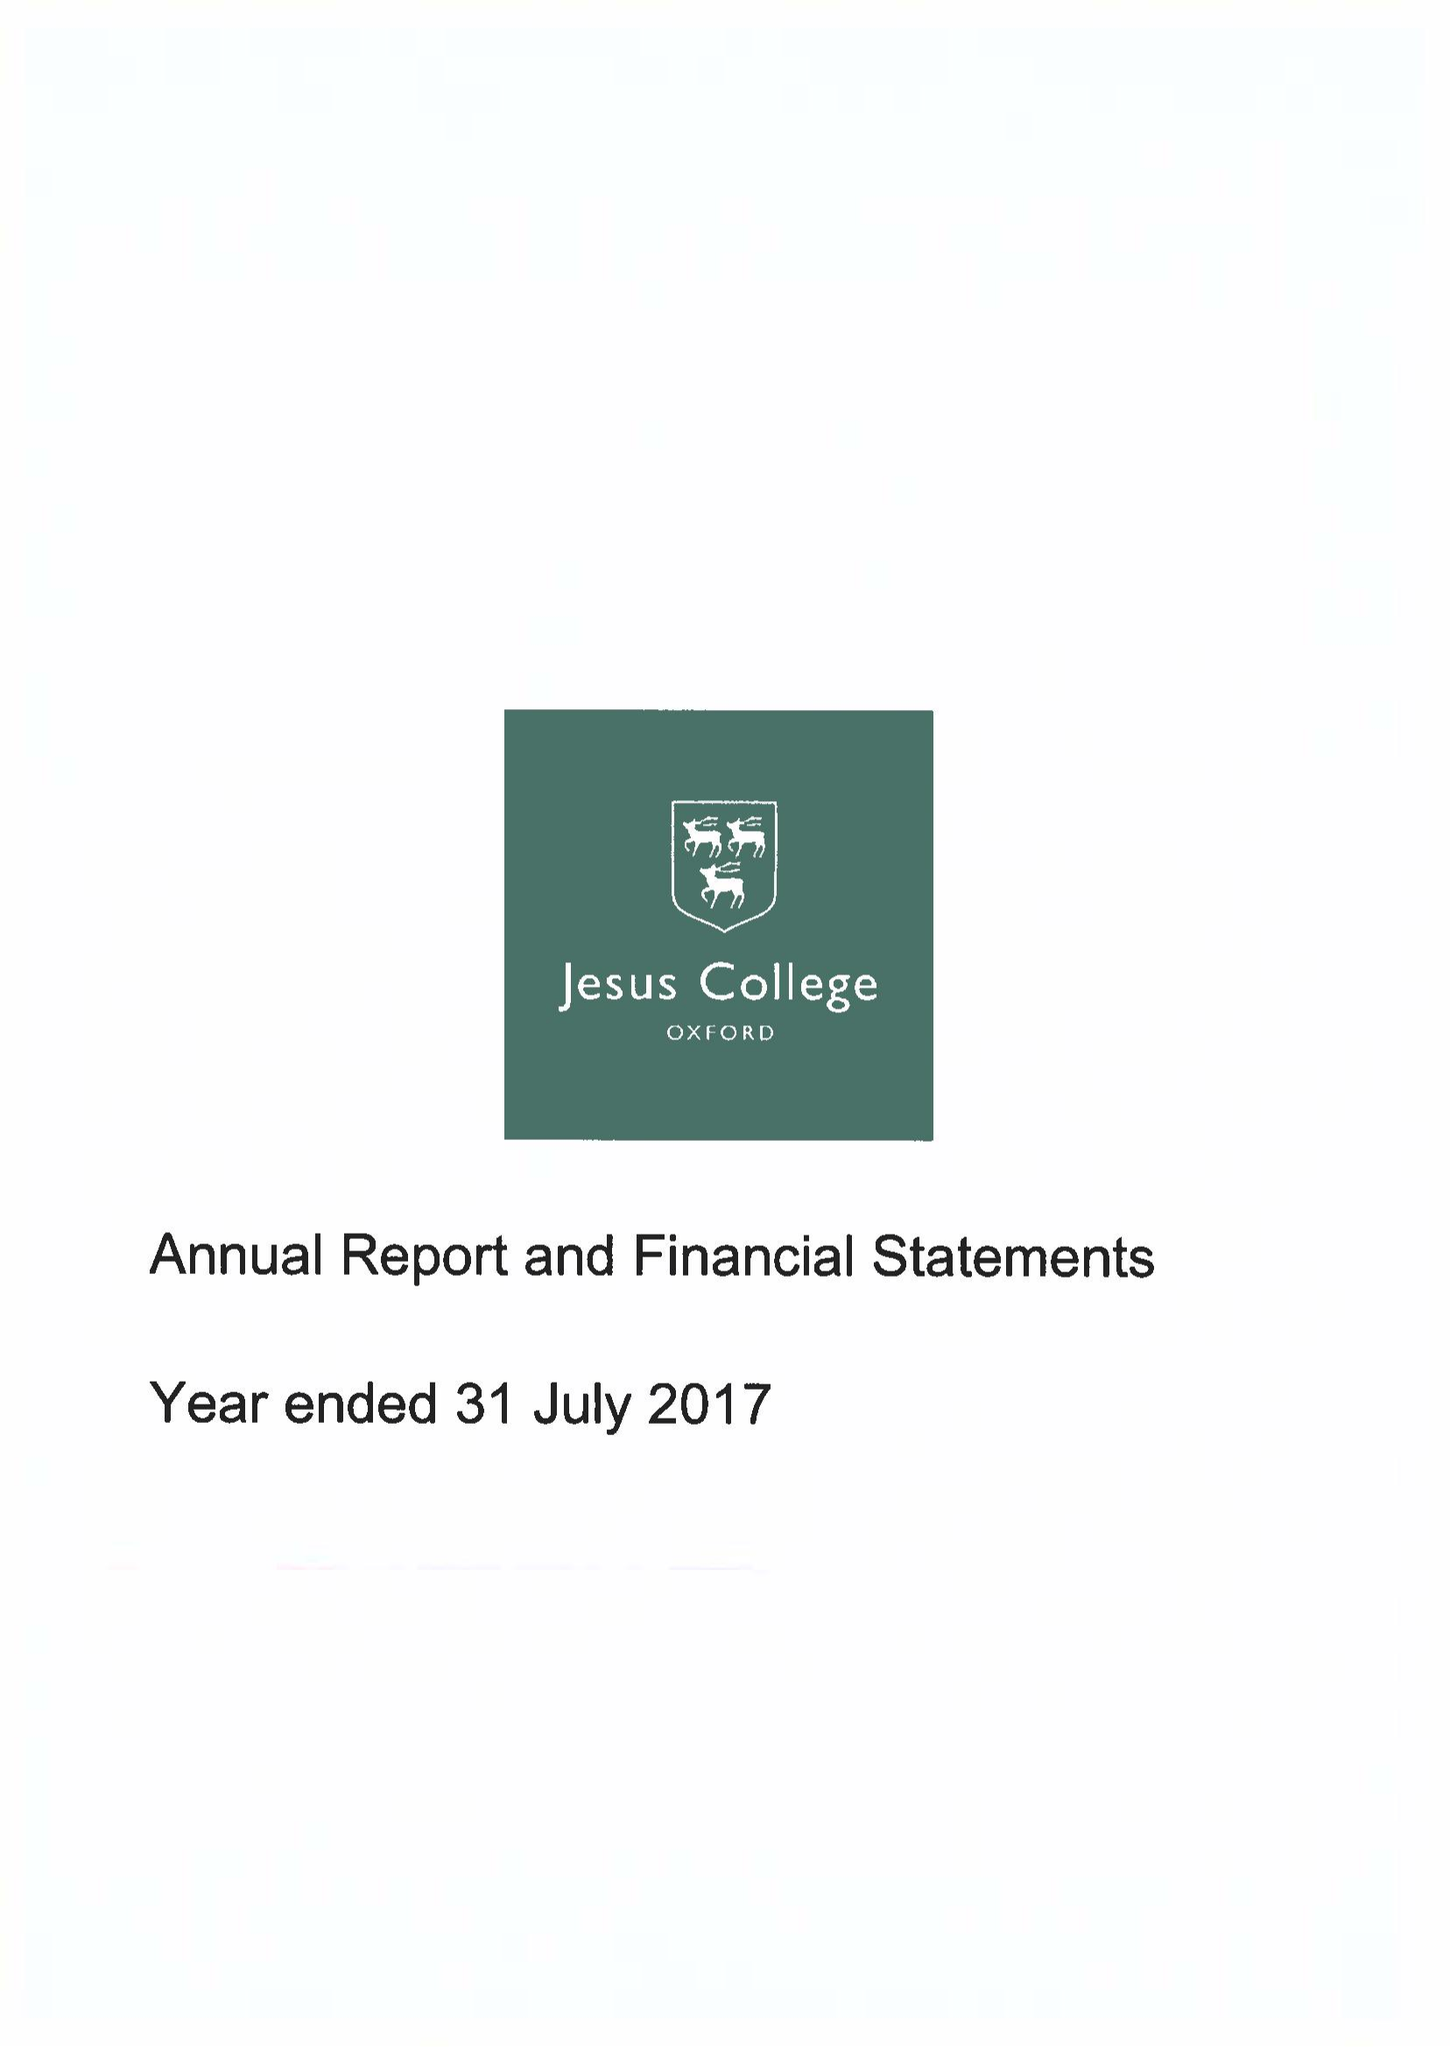What is the value for the address__street_line?
Answer the question using a single word or phrase. TURL STREET 